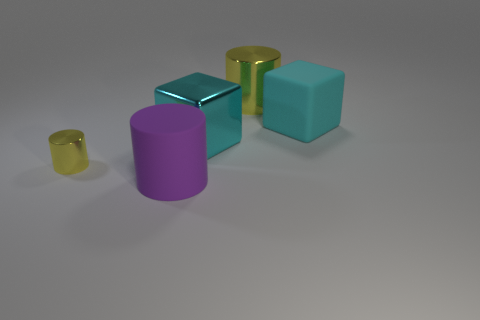Could you infer the lighting source from the shadows in the image? Based on the angles and lengths of the shadows cast by the objects, it appears that the main light source in the image is coming from the top left. The shadows are falling slightly towards the right and are relatively soft, which suggests the light source is not too close. 